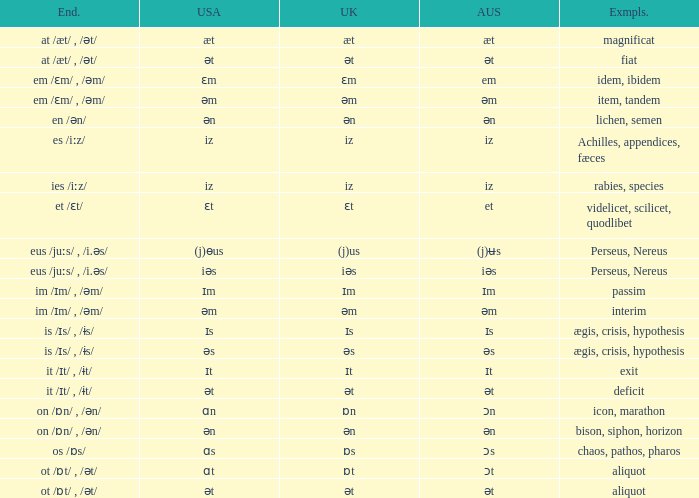Which Examples has Australian of əm? Item, tandem, interim. 